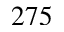<formula> <loc_0><loc_0><loc_500><loc_500>2 7 5</formula> 